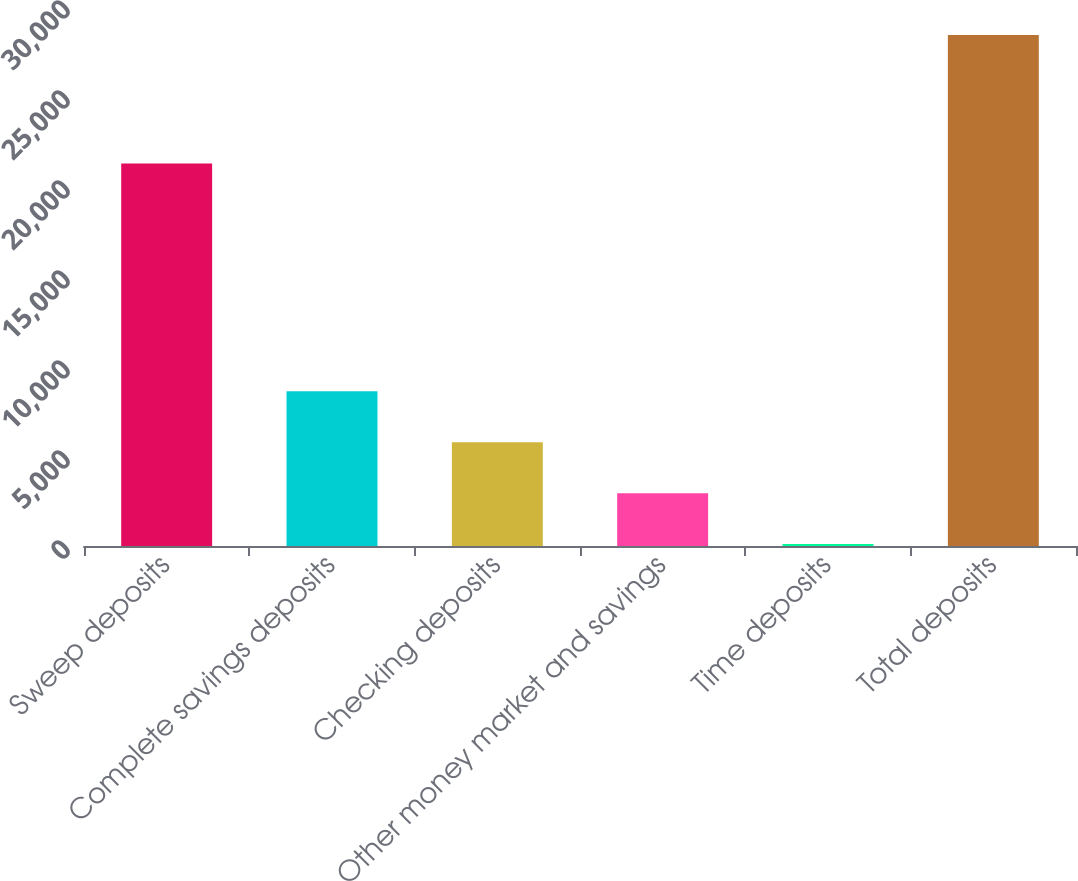<chart> <loc_0><loc_0><loc_500><loc_500><bar_chart><fcel>Sweep deposits<fcel>Complete savings deposits<fcel>Checking deposits<fcel>Other money market and savings<fcel>Time deposits<fcel>Total deposits<nl><fcel>21253.6<fcel>8592.44<fcel>5763.86<fcel>2935.28<fcel>106.7<fcel>28392.5<nl></chart> 